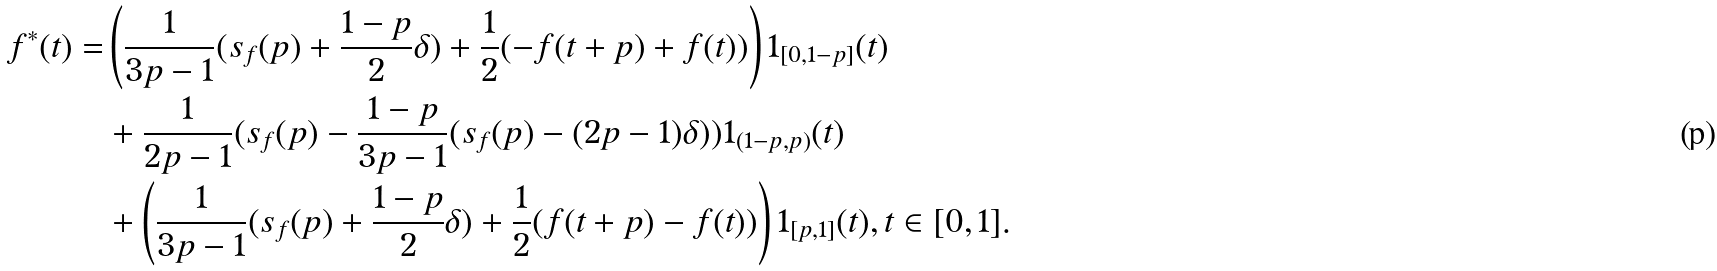Convert formula to latex. <formula><loc_0><loc_0><loc_500><loc_500>f ^ { * } ( t ) = & \left ( \frac { 1 } { 3 p - 1 } ( s _ { f } ( p ) + \frac { 1 - p } { 2 } \delta ) + \frac { 1 } { 2 } ( - f ( t + p ) + f ( t ) ) \right ) { 1 } _ { [ 0 , 1 - p ] } ( t ) \\ & + \frac { 1 } { 2 p - 1 } ( s _ { f } ( p ) - \frac { 1 - p } { 3 p - 1 } ( s _ { f } ( p ) - ( 2 p - 1 ) \delta ) ) { 1 } _ { ( 1 - p , p ) } ( t ) \\ & + \left ( \frac { 1 } { 3 p - 1 } ( s _ { f } ( p ) + \frac { 1 - p } { 2 } \delta ) + \frac { 1 } { 2 } ( f ( t + p ) - f ( t ) ) \right ) { 1 } _ { [ p , 1 ] } ( t ) , t \in [ 0 , 1 ] .</formula> 